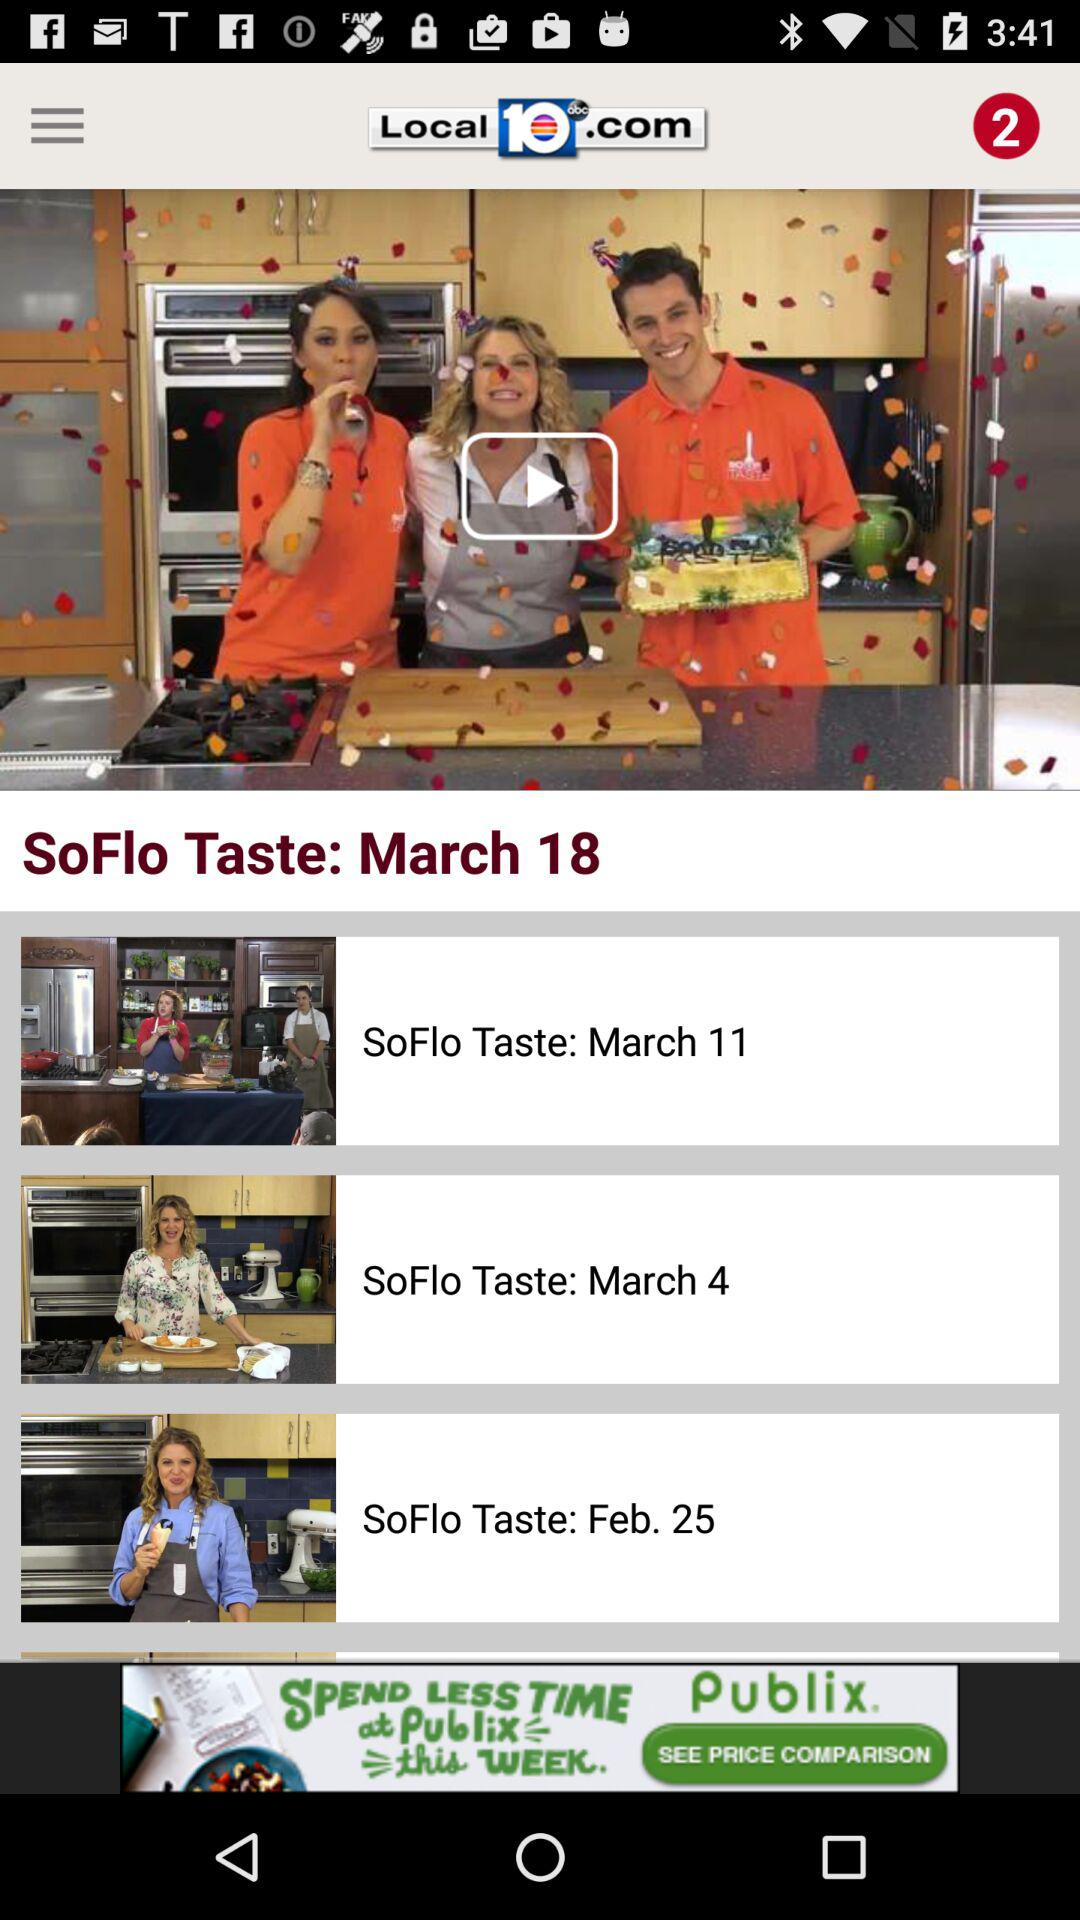What is the date of the episodes of "SoFlo Taste"? The dates of the episodes of "SoFlo Taste" are March 18, March 11, March 4 and February 25. 